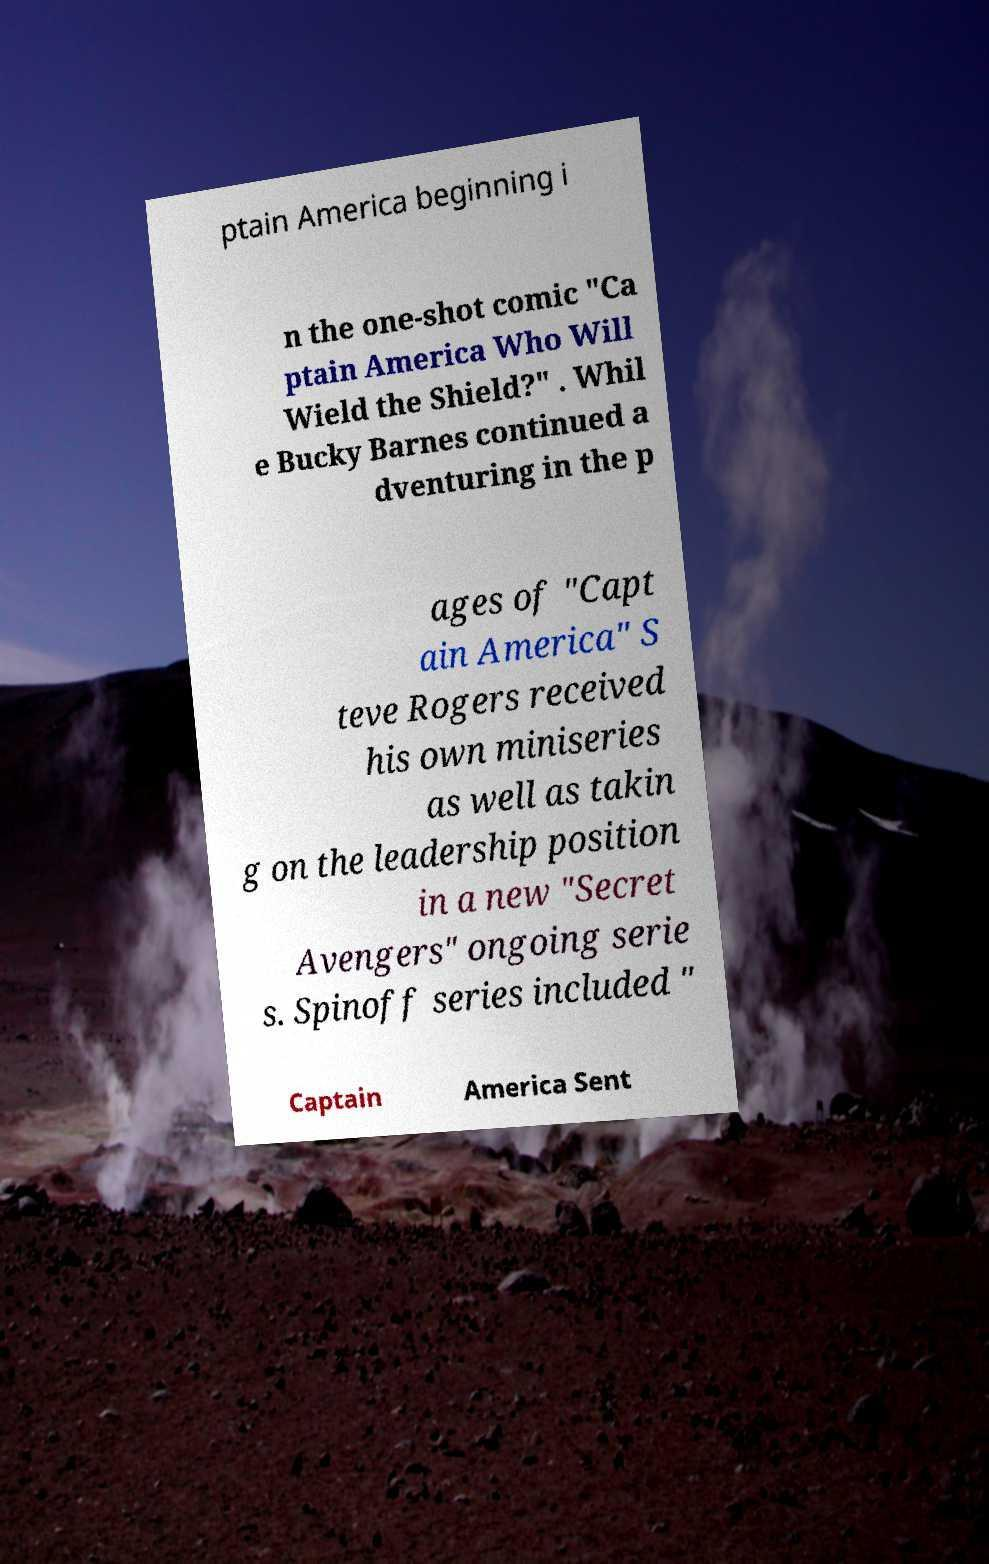Please read and relay the text visible in this image. What does it say? ptain America beginning i n the one-shot comic "Ca ptain America Who Will Wield the Shield?" . Whil e Bucky Barnes continued a dventuring in the p ages of "Capt ain America" S teve Rogers received his own miniseries as well as takin g on the leadership position in a new "Secret Avengers" ongoing serie s. Spinoff series included " Captain America Sent 